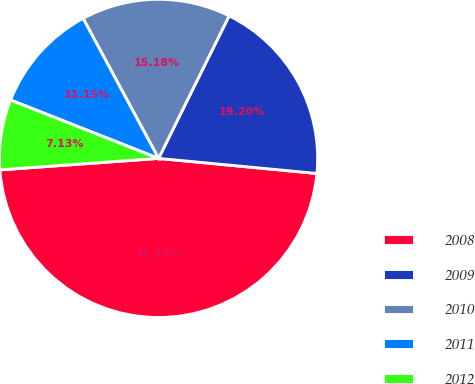Convert chart. <chart><loc_0><loc_0><loc_500><loc_500><pie_chart><fcel>2008<fcel>2009<fcel>2010<fcel>2011<fcel>2012<nl><fcel>47.34%<fcel>19.2%<fcel>15.18%<fcel>11.15%<fcel>7.13%<nl></chart> 